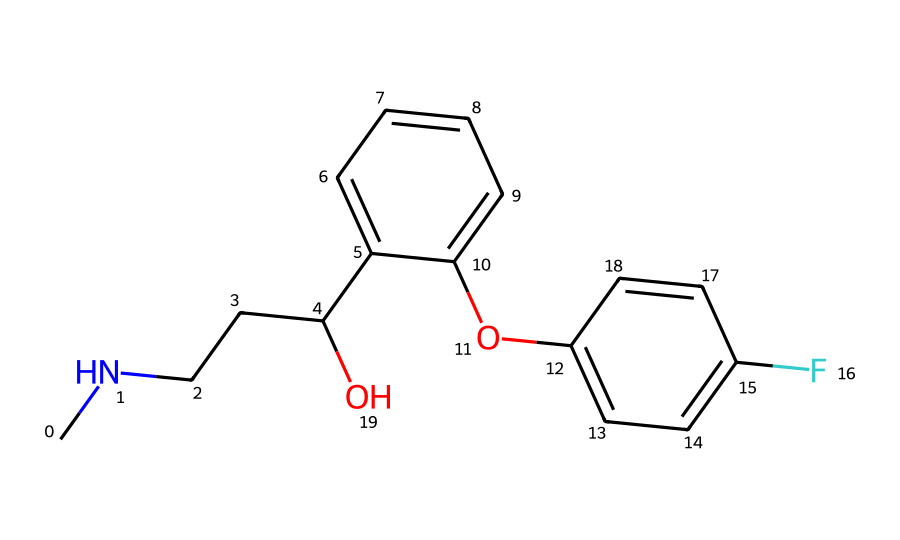How many carbon atoms are present in this chemical? Count the number of carbon atoms in the structure. Each vertex in the structure represents a carbon atom unless explicitly labeled otherwise. By carefully counting each carbon in the skeletal representation, we find there are 15 carbon atoms.
Answer: 15 What functional groups can be identified in this chemical? Analyze the structure for specific functional groups. The chemical has a hydroxyl group (-OH), an ether group (R-O-R'), and a fluorobenzene ring. Thus, we identify the presence of a hydroxyl group and an ether functional group.
Answer: hydroxyl and ether Is there a nitrogen atom present in this chemical? Inspect the SMILES representation and the structure for the presence of nitrogen (N). There is a nitrogen atom connected to a carbon chain, indicating its presence.
Answer: yes What type of drug is represented by this chemical structure? Consider the presence of the functional groups and the structure's overall properties. The combination suggests it is an antidepressant, typically characterized by structures that modify neurotransmitter levels.
Answer: antidepressant How many rings are present in this chemical structure? Look at the chemical diagram for ring structures. The visual representation shows there are two aromatic rings attached to the rest of the compound. Thus, we can identify that there are two rings in the structure.
Answer: 2 What effect do the substituents on the benzene rings have on social behavior? Evaluate the substituents on the rings, particularly noting that a fluorine atom might enhance receptor binding affinity. This suggests a potential impact on mood regulation, which can in turn affect social behavior positively.
Answer: improve Does this chemical have any chiral centers? Identify stereogenic centers by checking for carbon atoms bonded to four different substituents. In this structure, there are no such centers present, indicating the lack of chirality.
Answer: no 